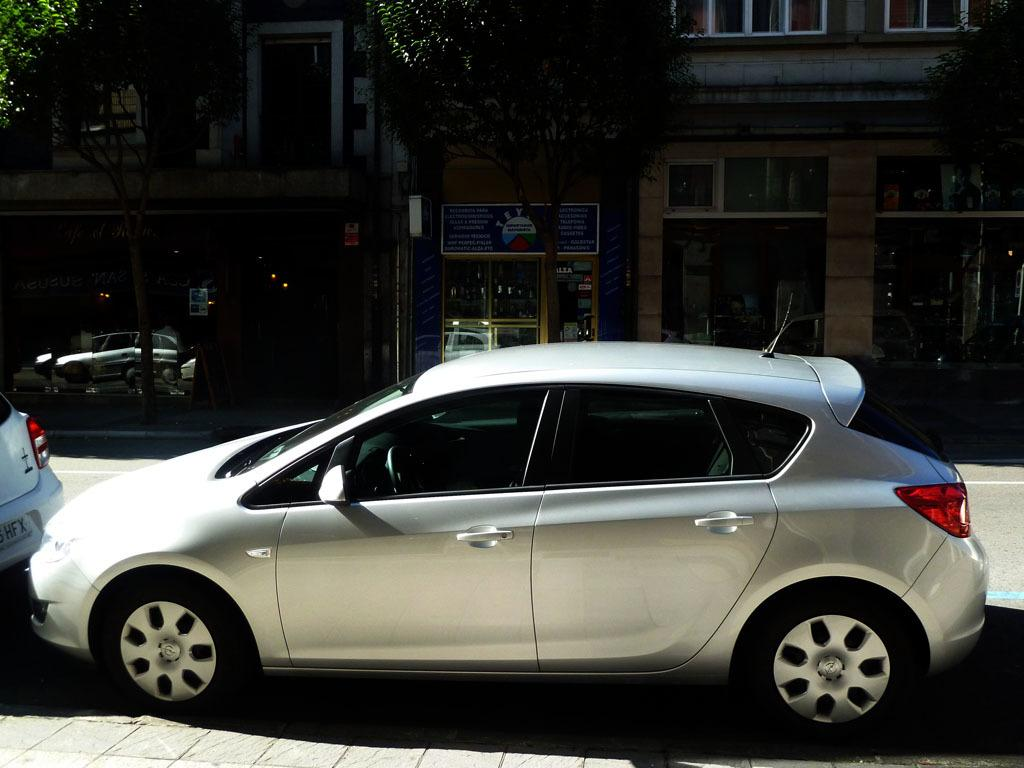How many cars can be seen in the image? There are two cars in the image. What are the cars doing in the image? The cars are parked on the road. What can be seen in the background of the image? There are trees and buildings in the background of the image. How many cows are grazing on the road in the image? There are no cows present in the image; it only features two parked cars. What type of wood is used to construct the buildings in the image? The image does not provide information about the materials used to construct the buildings, so we cannot determine the type of wood used. 